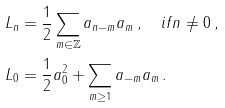Convert formula to latex. <formula><loc_0><loc_0><loc_500><loc_500>L _ { n } & = \frac { 1 } { 2 } \sum _ { m \in \mathbb { Z } } a _ { n - m } a _ { m } \, , \quad i f n \neq 0 \, , \\ L _ { 0 } & = \frac { 1 } { 2 } a _ { 0 } ^ { 2 } + \sum _ { m \geq 1 } a _ { - m } a _ { m } \, .</formula> 